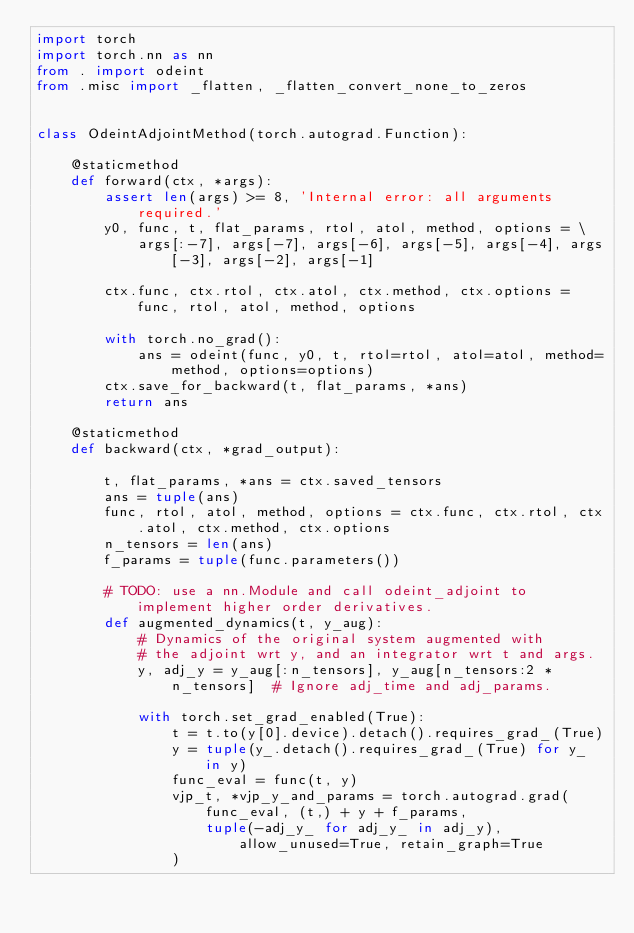Convert code to text. <code><loc_0><loc_0><loc_500><loc_500><_Python_>import torch
import torch.nn as nn
from . import odeint
from .misc import _flatten, _flatten_convert_none_to_zeros


class OdeintAdjointMethod(torch.autograd.Function):

    @staticmethod
    def forward(ctx, *args):
        assert len(args) >= 8, 'Internal error: all arguments required.'
        y0, func, t, flat_params, rtol, atol, method, options = \
            args[:-7], args[-7], args[-6], args[-5], args[-4], args[-3], args[-2], args[-1]

        ctx.func, ctx.rtol, ctx.atol, ctx.method, ctx.options = func, rtol, atol, method, options

        with torch.no_grad():
            ans = odeint(func, y0, t, rtol=rtol, atol=atol, method=method, options=options)
        ctx.save_for_backward(t, flat_params, *ans)
        return ans

    @staticmethod
    def backward(ctx, *grad_output):

        t, flat_params, *ans = ctx.saved_tensors
        ans = tuple(ans)
        func, rtol, atol, method, options = ctx.func, ctx.rtol, ctx.atol, ctx.method, ctx.options
        n_tensors = len(ans)
        f_params = tuple(func.parameters())

        # TODO: use a nn.Module and call odeint_adjoint to implement higher order derivatives.
        def augmented_dynamics(t, y_aug):
            # Dynamics of the original system augmented with
            # the adjoint wrt y, and an integrator wrt t and args.
            y, adj_y = y_aug[:n_tensors], y_aug[n_tensors:2 * n_tensors]  # Ignore adj_time and adj_params.

            with torch.set_grad_enabled(True):
                t = t.to(y[0].device).detach().requires_grad_(True)
                y = tuple(y_.detach().requires_grad_(True) for y_ in y)
                func_eval = func(t, y)
                vjp_t, *vjp_y_and_params = torch.autograd.grad(
                    func_eval, (t,) + y + f_params,
                    tuple(-adj_y_ for adj_y_ in adj_y), allow_unused=True, retain_graph=True
                )</code> 